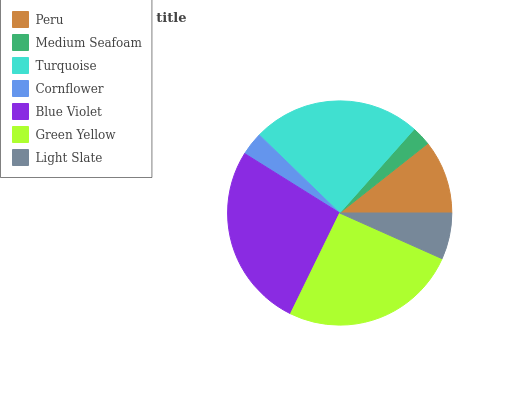Is Medium Seafoam the minimum?
Answer yes or no. Yes. Is Blue Violet the maximum?
Answer yes or no. Yes. Is Turquoise the minimum?
Answer yes or no. No. Is Turquoise the maximum?
Answer yes or no. No. Is Turquoise greater than Medium Seafoam?
Answer yes or no. Yes. Is Medium Seafoam less than Turquoise?
Answer yes or no. Yes. Is Medium Seafoam greater than Turquoise?
Answer yes or no. No. Is Turquoise less than Medium Seafoam?
Answer yes or no. No. Is Peru the high median?
Answer yes or no. Yes. Is Peru the low median?
Answer yes or no. Yes. Is Light Slate the high median?
Answer yes or no. No. Is Turquoise the low median?
Answer yes or no. No. 